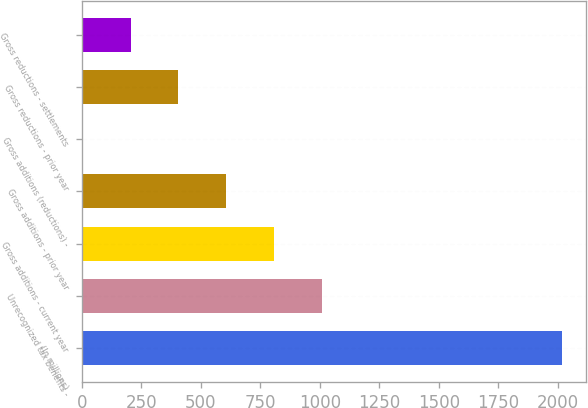Convert chart. <chart><loc_0><loc_0><loc_500><loc_500><bar_chart><fcel>(In millions)<fcel>Unrecognized tax benefits -<fcel>Gross additions - current year<fcel>Gross additions - prior year<fcel>Gross additions (reductions) -<fcel>Gross reductions - prior year<fcel>Gross reductions - settlements<nl><fcel>2017<fcel>1010.5<fcel>809.2<fcel>607.9<fcel>4<fcel>406.6<fcel>205.3<nl></chart> 